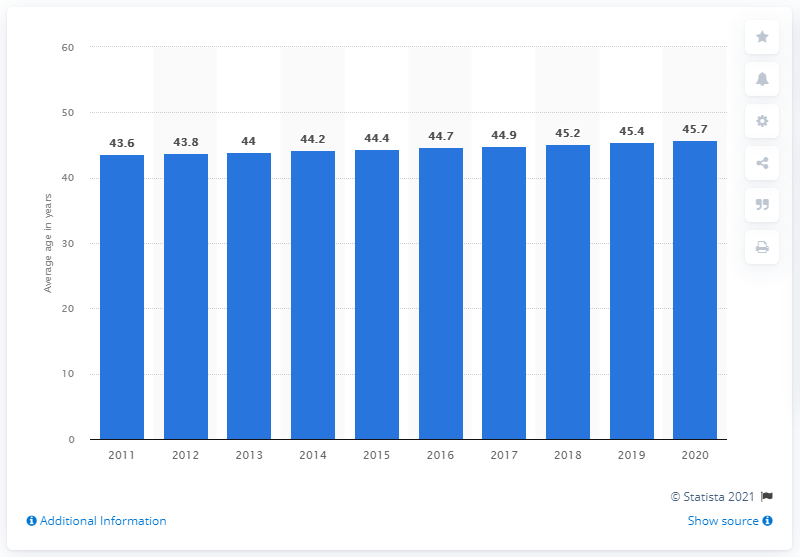Highlight a few significant elements in this photo. The average age of Italians in 2011 was 43.6 years. The median age of the Italian population was projected to increase in the year 2019. 